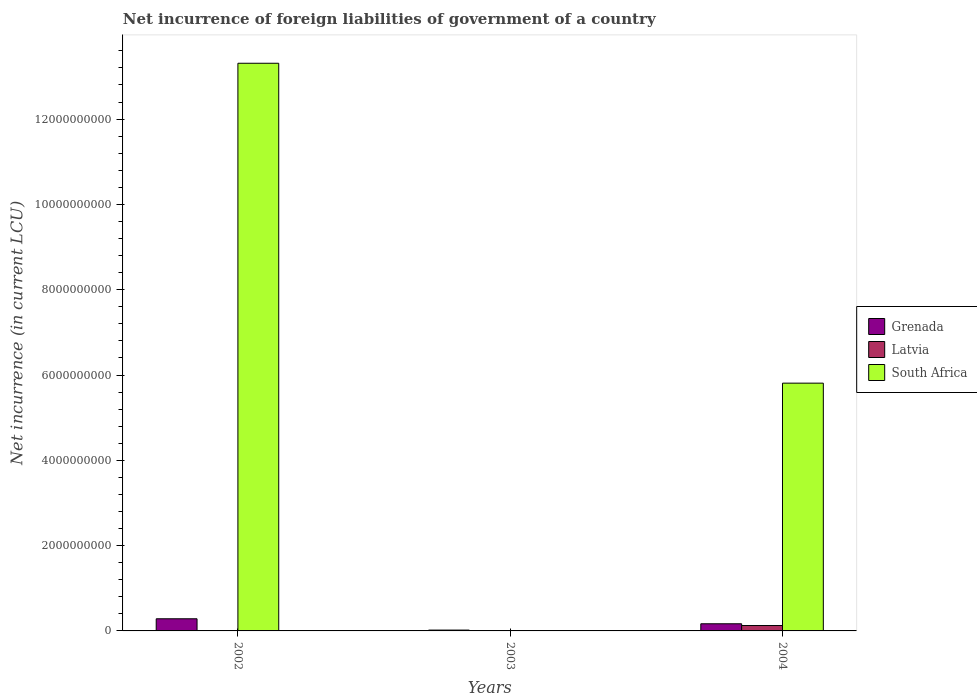How many different coloured bars are there?
Provide a short and direct response. 3. Are the number of bars per tick equal to the number of legend labels?
Give a very brief answer. No. Are the number of bars on each tick of the X-axis equal?
Keep it short and to the point. No. How many bars are there on the 1st tick from the right?
Offer a very short reply. 3. What is the label of the 3rd group of bars from the left?
Give a very brief answer. 2004. In how many cases, is the number of bars for a given year not equal to the number of legend labels?
Give a very brief answer. 1. What is the net incurrence of foreign liabilities in Grenada in 2004?
Ensure brevity in your answer.  1.68e+08. Across all years, what is the maximum net incurrence of foreign liabilities in South Africa?
Provide a succinct answer. 1.33e+1. Across all years, what is the minimum net incurrence of foreign liabilities in Latvia?
Your response must be concise. 0. In which year was the net incurrence of foreign liabilities in South Africa maximum?
Offer a terse response. 2002. What is the total net incurrence of foreign liabilities in Latvia in the graph?
Ensure brevity in your answer.  1.34e+08. What is the difference between the net incurrence of foreign liabilities in Grenada in 2003 and that in 2004?
Ensure brevity in your answer.  -1.48e+08. What is the difference between the net incurrence of foreign liabilities in Latvia in 2003 and the net incurrence of foreign liabilities in South Africa in 2002?
Ensure brevity in your answer.  -1.33e+1. What is the average net incurrence of foreign liabilities in Latvia per year?
Your response must be concise. 4.47e+07. In the year 2002, what is the difference between the net incurrence of foreign liabilities in South Africa and net incurrence of foreign liabilities in Latvia?
Your answer should be compact. 1.33e+1. What is the ratio of the net incurrence of foreign liabilities in Grenada in 2002 to that in 2003?
Offer a terse response. 14.45. Is the net incurrence of foreign liabilities in Latvia in 2002 less than that in 2004?
Keep it short and to the point. Yes. Is the difference between the net incurrence of foreign liabilities in South Africa in 2002 and 2004 greater than the difference between the net incurrence of foreign liabilities in Latvia in 2002 and 2004?
Provide a succinct answer. Yes. What is the difference between the highest and the second highest net incurrence of foreign liabilities in Grenada?
Ensure brevity in your answer.  1.17e+08. What is the difference between the highest and the lowest net incurrence of foreign liabilities in Grenada?
Keep it short and to the point. 2.65e+08. How many bars are there?
Offer a very short reply. 7. Does the graph contain grids?
Give a very brief answer. No. How are the legend labels stacked?
Ensure brevity in your answer.  Vertical. What is the title of the graph?
Your answer should be compact. Net incurrence of foreign liabilities of government of a country. Does "Least developed countries" appear as one of the legend labels in the graph?
Give a very brief answer. No. What is the label or title of the X-axis?
Keep it short and to the point. Years. What is the label or title of the Y-axis?
Your answer should be very brief. Net incurrence (in current LCU). What is the Net incurrence (in current LCU) in Grenada in 2002?
Your answer should be very brief. 2.85e+08. What is the Net incurrence (in current LCU) in Latvia in 2002?
Your response must be concise. 7.60e+06. What is the Net incurrence (in current LCU) of South Africa in 2002?
Your answer should be very brief. 1.33e+1. What is the Net incurrence (in current LCU) of Grenada in 2003?
Ensure brevity in your answer.  1.97e+07. What is the Net incurrence (in current LCU) in Latvia in 2003?
Offer a terse response. 0. What is the Net incurrence (in current LCU) in Grenada in 2004?
Your response must be concise. 1.68e+08. What is the Net incurrence (in current LCU) in Latvia in 2004?
Ensure brevity in your answer.  1.27e+08. What is the Net incurrence (in current LCU) in South Africa in 2004?
Provide a succinct answer. 5.81e+09. Across all years, what is the maximum Net incurrence (in current LCU) of Grenada?
Your answer should be compact. 2.85e+08. Across all years, what is the maximum Net incurrence (in current LCU) in Latvia?
Your response must be concise. 1.27e+08. Across all years, what is the maximum Net incurrence (in current LCU) in South Africa?
Make the answer very short. 1.33e+1. Across all years, what is the minimum Net incurrence (in current LCU) of Grenada?
Your answer should be compact. 1.97e+07. Across all years, what is the minimum Net incurrence (in current LCU) in Latvia?
Offer a terse response. 0. What is the total Net incurrence (in current LCU) of Grenada in the graph?
Offer a very short reply. 4.72e+08. What is the total Net incurrence (in current LCU) in Latvia in the graph?
Ensure brevity in your answer.  1.34e+08. What is the total Net incurrence (in current LCU) of South Africa in the graph?
Give a very brief answer. 1.91e+1. What is the difference between the Net incurrence (in current LCU) of Grenada in 2002 and that in 2003?
Offer a terse response. 2.65e+08. What is the difference between the Net incurrence (in current LCU) in Grenada in 2002 and that in 2004?
Offer a terse response. 1.17e+08. What is the difference between the Net incurrence (in current LCU) in Latvia in 2002 and that in 2004?
Provide a short and direct response. -1.19e+08. What is the difference between the Net incurrence (in current LCU) in South Africa in 2002 and that in 2004?
Make the answer very short. 7.50e+09. What is the difference between the Net incurrence (in current LCU) in Grenada in 2003 and that in 2004?
Make the answer very short. -1.48e+08. What is the difference between the Net incurrence (in current LCU) in Grenada in 2002 and the Net incurrence (in current LCU) in Latvia in 2004?
Your response must be concise. 1.58e+08. What is the difference between the Net incurrence (in current LCU) in Grenada in 2002 and the Net incurrence (in current LCU) in South Africa in 2004?
Offer a very short reply. -5.52e+09. What is the difference between the Net incurrence (in current LCU) in Latvia in 2002 and the Net incurrence (in current LCU) in South Africa in 2004?
Ensure brevity in your answer.  -5.80e+09. What is the difference between the Net incurrence (in current LCU) in Grenada in 2003 and the Net incurrence (in current LCU) in Latvia in 2004?
Provide a short and direct response. -1.07e+08. What is the difference between the Net incurrence (in current LCU) in Grenada in 2003 and the Net incurrence (in current LCU) in South Africa in 2004?
Offer a terse response. -5.79e+09. What is the average Net incurrence (in current LCU) of Grenada per year?
Keep it short and to the point. 1.57e+08. What is the average Net incurrence (in current LCU) of Latvia per year?
Your answer should be very brief. 4.47e+07. What is the average Net incurrence (in current LCU) in South Africa per year?
Provide a succinct answer. 6.37e+09. In the year 2002, what is the difference between the Net incurrence (in current LCU) of Grenada and Net incurrence (in current LCU) of Latvia?
Offer a terse response. 2.77e+08. In the year 2002, what is the difference between the Net incurrence (in current LCU) in Grenada and Net incurrence (in current LCU) in South Africa?
Make the answer very short. -1.30e+1. In the year 2002, what is the difference between the Net incurrence (in current LCU) of Latvia and Net incurrence (in current LCU) of South Africa?
Your answer should be very brief. -1.33e+1. In the year 2004, what is the difference between the Net incurrence (in current LCU) of Grenada and Net incurrence (in current LCU) of Latvia?
Keep it short and to the point. 4.11e+07. In the year 2004, what is the difference between the Net incurrence (in current LCU) of Grenada and Net incurrence (in current LCU) of South Africa?
Give a very brief answer. -5.64e+09. In the year 2004, what is the difference between the Net incurrence (in current LCU) of Latvia and Net incurrence (in current LCU) of South Africa?
Offer a very short reply. -5.68e+09. What is the ratio of the Net incurrence (in current LCU) of Grenada in 2002 to that in 2003?
Your answer should be compact. 14.45. What is the ratio of the Net incurrence (in current LCU) of Grenada in 2002 to that in 2004?
Ensure brevity in your answer.  1.7. What is the ratio of the Net incurrence (in current LCU) in South Africa in 2002 to that in 2004?
Provide a succinct answer. 2.29. What is the ratio of the Net incurrence (in current LCU) of Grenada in 2003 to that in 2004?
Ensure brevity in your answer.  0.12. What is the difference between the highest and the second highest Net incurrence (in current LCU) in Grenada?
Give a very brief answer. 1.17e+08. What is the difference between the highest and the lowest Net incurrence (in current LCU) in Grenada?
Provide a succinct answer. 2.65e+08. What is the difference between the highest and the lowest Net incurrence (in current LCU) in Latvia?
Your response must be concise. 1.27e+08. What is the difference between the highest and the lowest Net incurrence (in current LCU) in South Africa?
Give a very brief answer. 1.33e+1. 